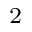<formula> <loc_0><loc_0><loc_500><loc_500>^ { 2 }</formula> 